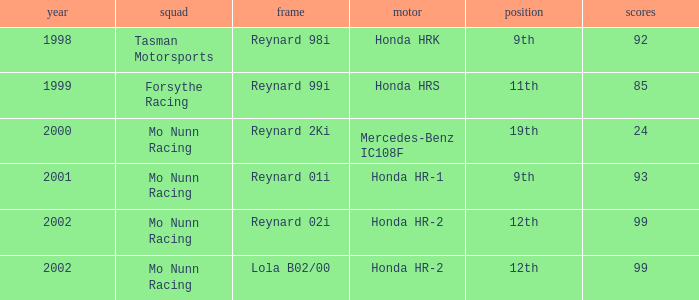Parse the full table. {'header': ['year', 'squad', 'frame', 'motor', 'position', 'scores'], 'rows': [['1998', 'Tasman Motorsports', 'Reynard 98i', 'Honda HRK', '9th', '92'], ['1999', 'Forsythe Racing', 'Reynard 99i', 'Honda HRS', '11th', '85'], ['2000', 'Mo Nunn Racing', 'Reynard 2Ki', 'Mercedes-Benz IC108F', '19th', '24'], ['2001', 'Mo Nunn Racing', 'Reynard 01i', 'Honda HR-1', '9th', '93'], ['2002', 'Mo Nunn Racing', 'Reynard 02i', 'Honda HR-2', '12th', '99'], ['2002', 'Mo Nunn Racing', 'Lola B02/00', 'Honda HR-2', '12th', '99']]} What is the total number of points of the honda hr-1 engine? 1.0. 